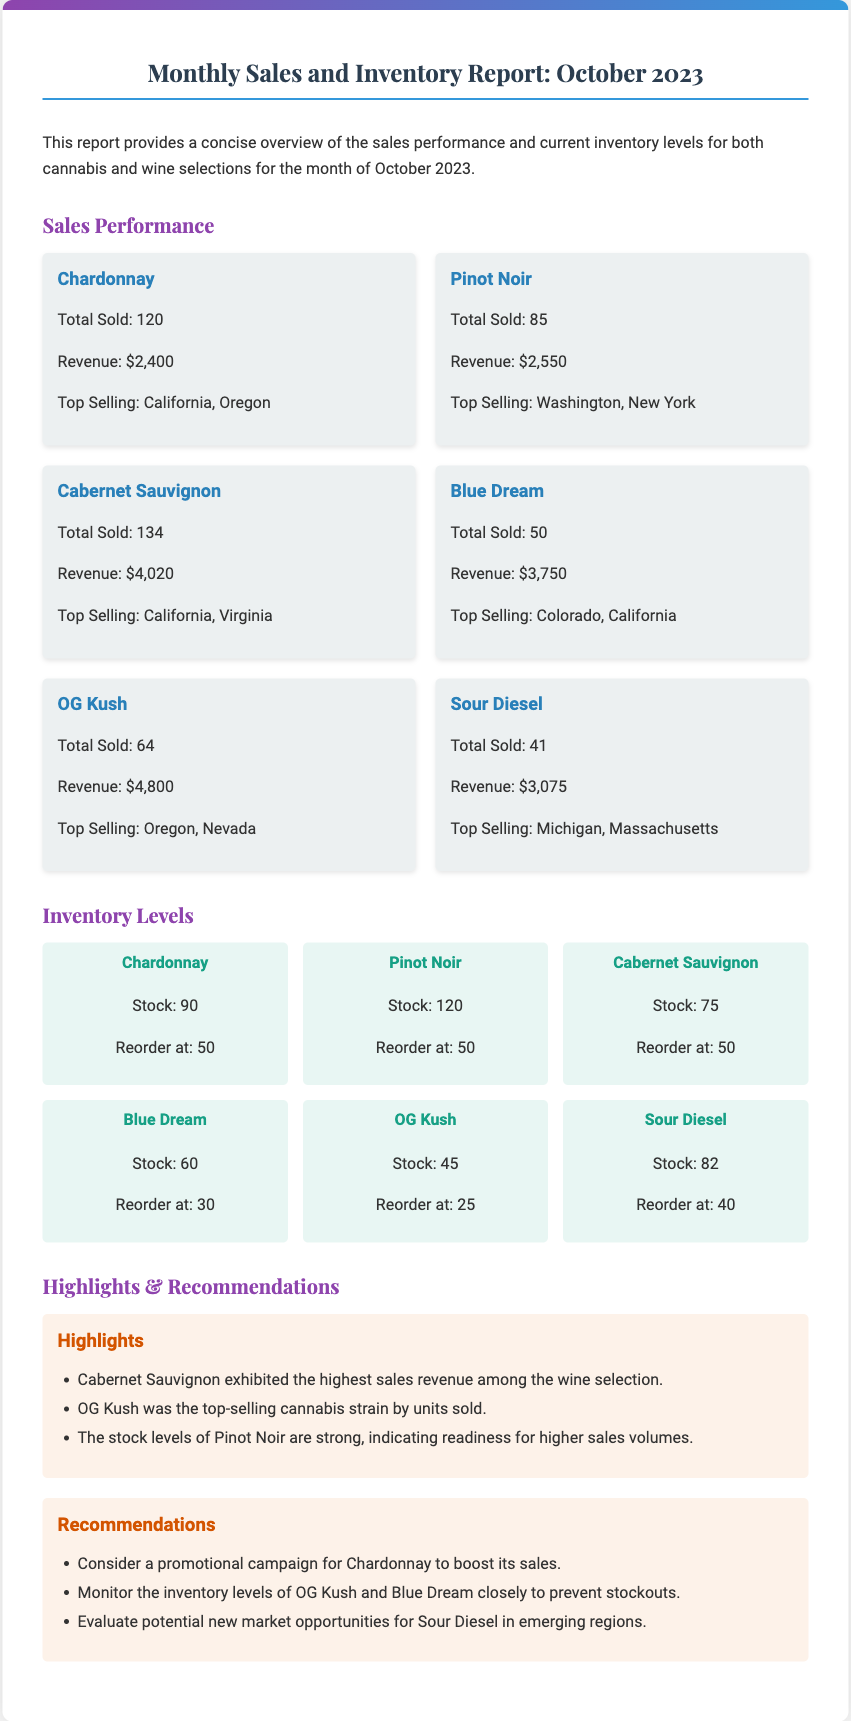What is the total revenue from Cabernet Sauvignon? The revenue for Cabernet Sauvignon is specifically listed in the document as $4,020.
Answer: $4,020 How many units of OG Kush were sold? The document states that 64 units of OG Kush were sold.
Answer: 64 What is the stock level for Chardonnay? The current stock level for Chardonnay is detailed as 90 in the inventory section.
Answer: 90 Which wine had the highest sales revenue? The report highlights that Cabernet Sauvignon exhibited the highest sales revenue among the wine selection.
Answer: Cabernet Sauvignon What is the reorder level for Blue Dream? The document indicates that Blue Dream should be reordered at a level of 30.
Answer: 30 Which cannabis strain was the top-selling by units sold? The report mentions OG Kush as the top-selling cannabis strain by units sold.
Answer: OG Kush How many total Pinot Noir units were sold? The total sold for Pinot Noir is explicitly mentioned as 85 units in the sales section.
Answer: 85 What promotional strategy is recommended for Chardonnay? The recommendations suggest considering a promotional campaign for Chardonnay to boost its sales.
Answer: Promotional campaign What is the stock level for Sour Diesel? The inventory level for Sour Diesel is stated as 82.
Answer: 82 